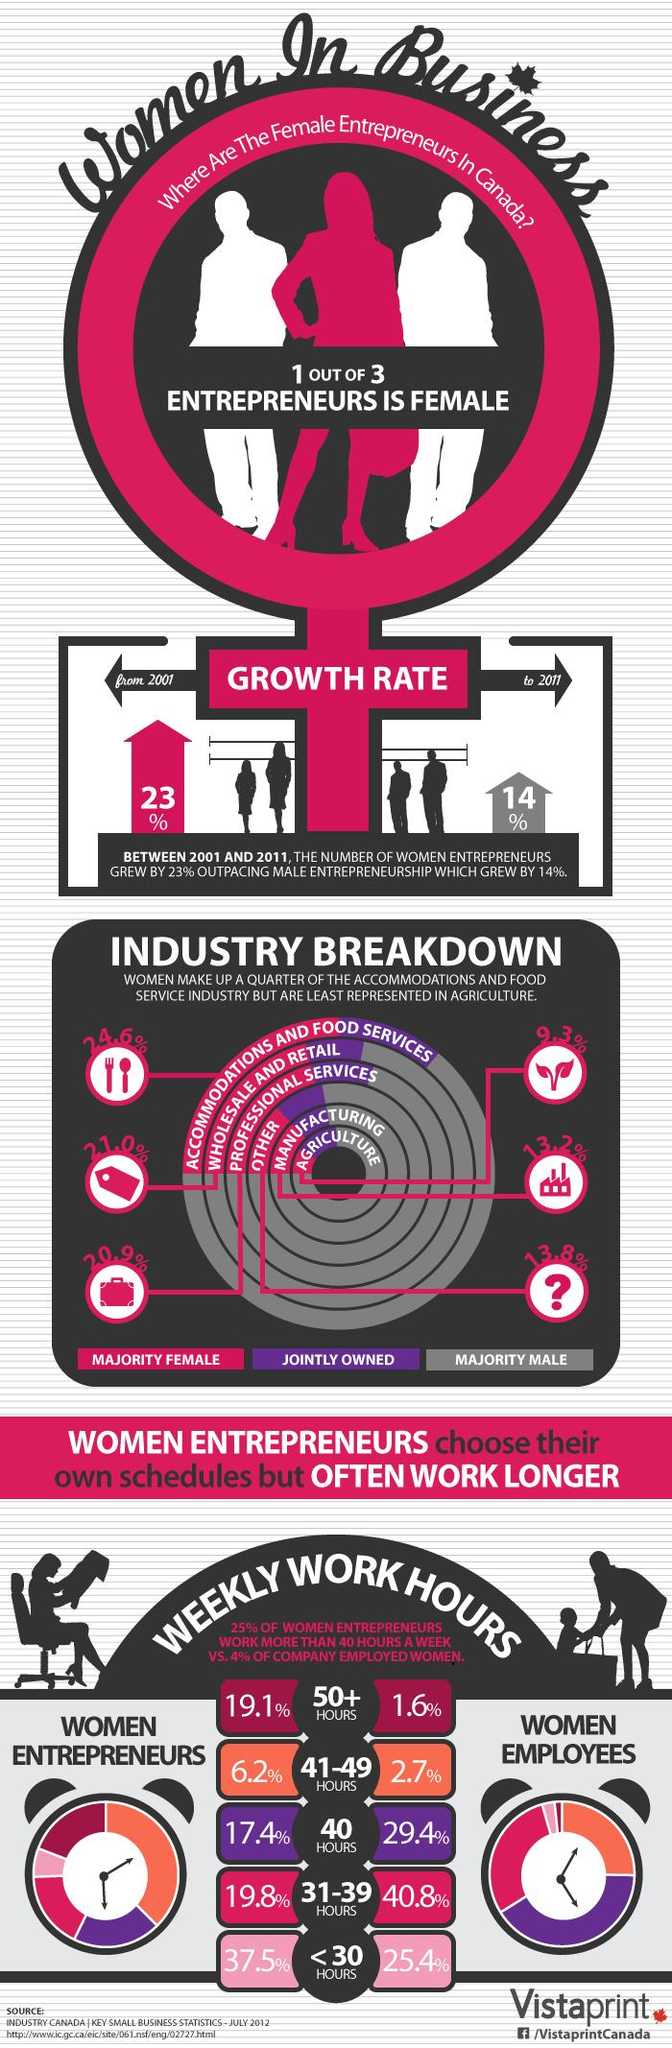Mention a couple of crucial points in this snapshot. In Canada, only 2.7% of women employees work for 41-49 hours per week. According to recent data, the majority of individuals working in the manufacturing industry in Canada are female, with a percentage of 13.2%. According to a recent study, 37.5% of women entrepreneurs in Canada work fewer than 30 hours per week. According to statistics, only 1.6% of women employees in Canada work for more than 50 hours a week. According to data from the Canadian government, the majority of individuals employed in the wholesale and retail industry are female, with a percentage of 21.0%. 